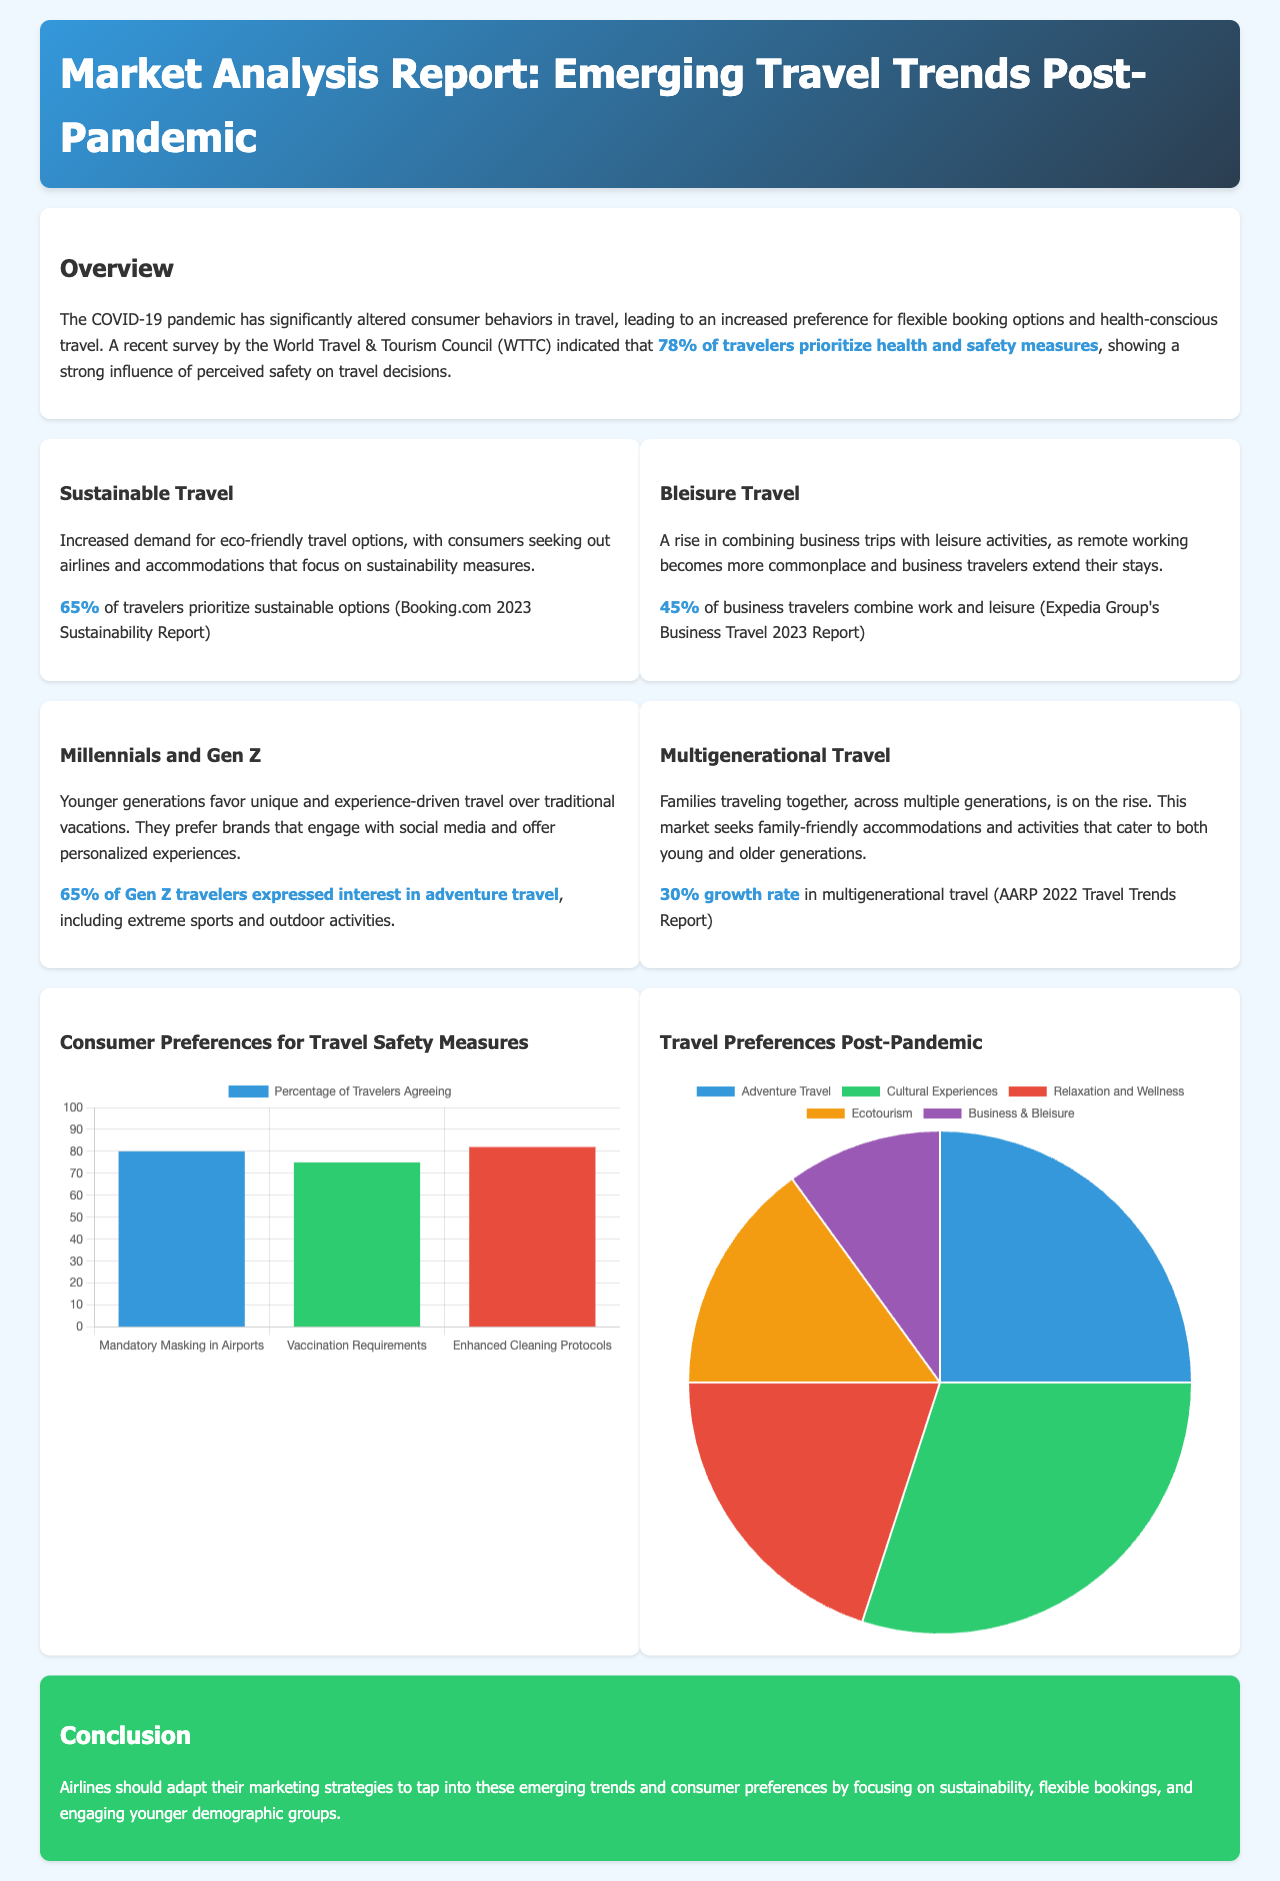what percentage of travelers prioritize health and safety measures? The document states that 78% of travelers prioritize health and safety measures based on a survey by the World Travel & Tourism Council.
Answer: 78% what is the growth rate in multigenerational travel? The document mentions a 30% growth rate in multigenerational travel according to AARP's 2022 Travel Trends Report.
Answer: 30% which generation shows a 65% interest in adventure travel? The document indicates that 65% of Gen Z travelers expressed interest in adventure travel.
Answer: Gen Z what are the three safety measures agreed upon by the highest percentage of travelers? The chart presents mandatory masking in airports, vaccination requirements, and enhanced cleaning protocols.
Answer: Mandatory Masking in Airports, Vaccination Requirements, Enhanced Cleaning Protocols what percentage of business travelers combine work and leisure? The document notes that 45% of business travelers combine work and leisure based on a report by Expedia Group.
Answer: 45% what is the predominant preference in travel after the pandemic according to the pie chart? The pie chart indicates that 30% of travelers prefer cultural experiences post-pandemic.
Answer: Cultural Experiences how many travelers prioritize sustainable options according to Booking.com 2023? The text highlights that 65% of travelers prioritize sustainable options according to Booking.com 2023 Sustainability Report.
Answer: 65% what is highlighted as a major focus for airlines in their marketing strategies? The conclusion emphasizes that airlines should focus on sustainability, flexible bookings, and engaging younger demographic groups.
Answer: Sustainability, flexible bookings, engaging younger demographic groups what is the overall appearance of the document? The document features a header with a gradient background, sections with white cards for content, and various charts to display information visually.
Answer: Visual graphs and consumer insights in well-organized sections 